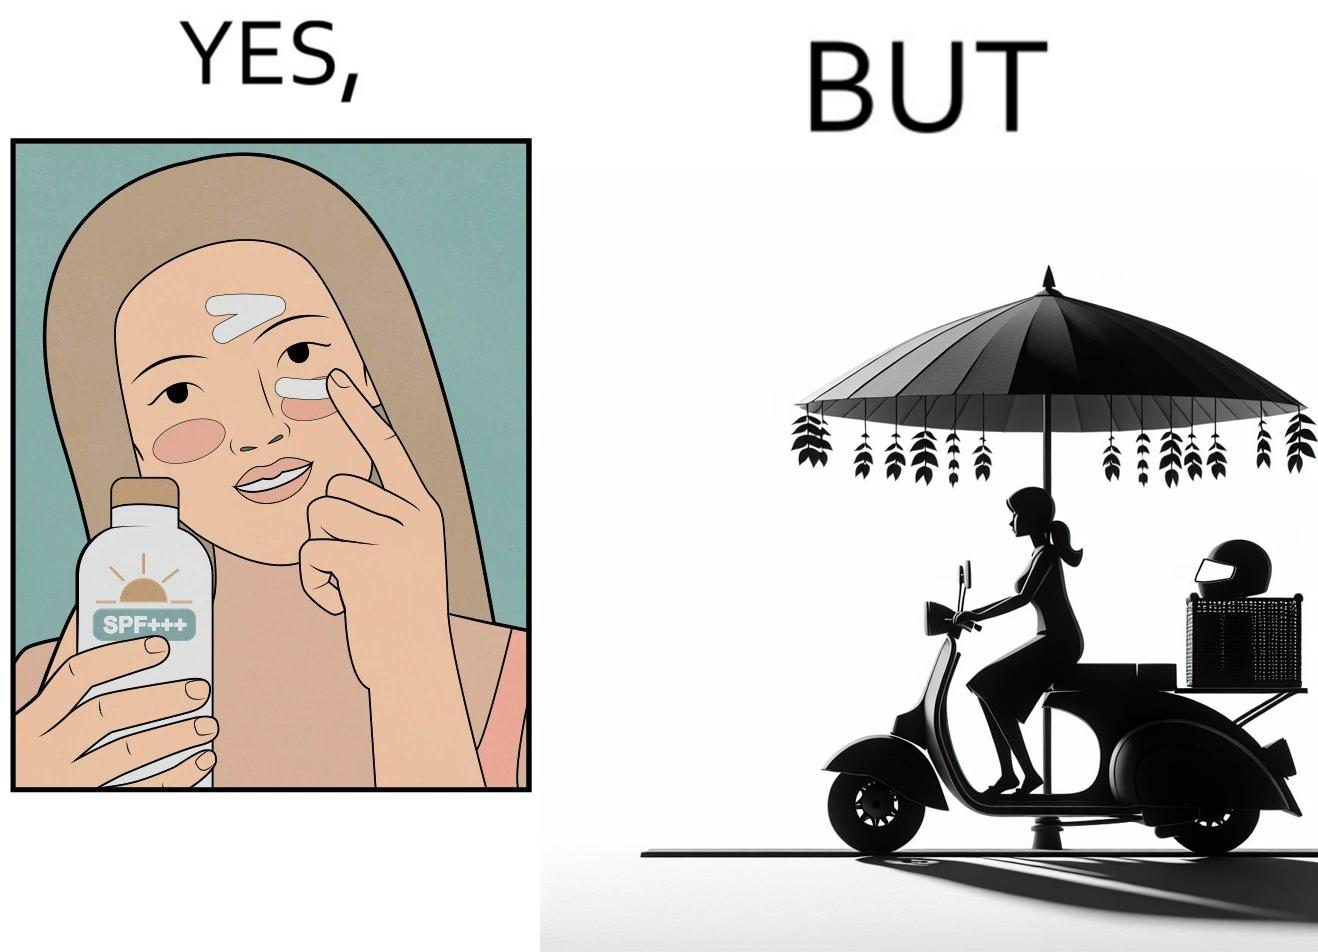What is shown in this image? The image is funny because while the woman is concerned about protection from the sun rays, she is not concerned about her safety while riding a scooter. 